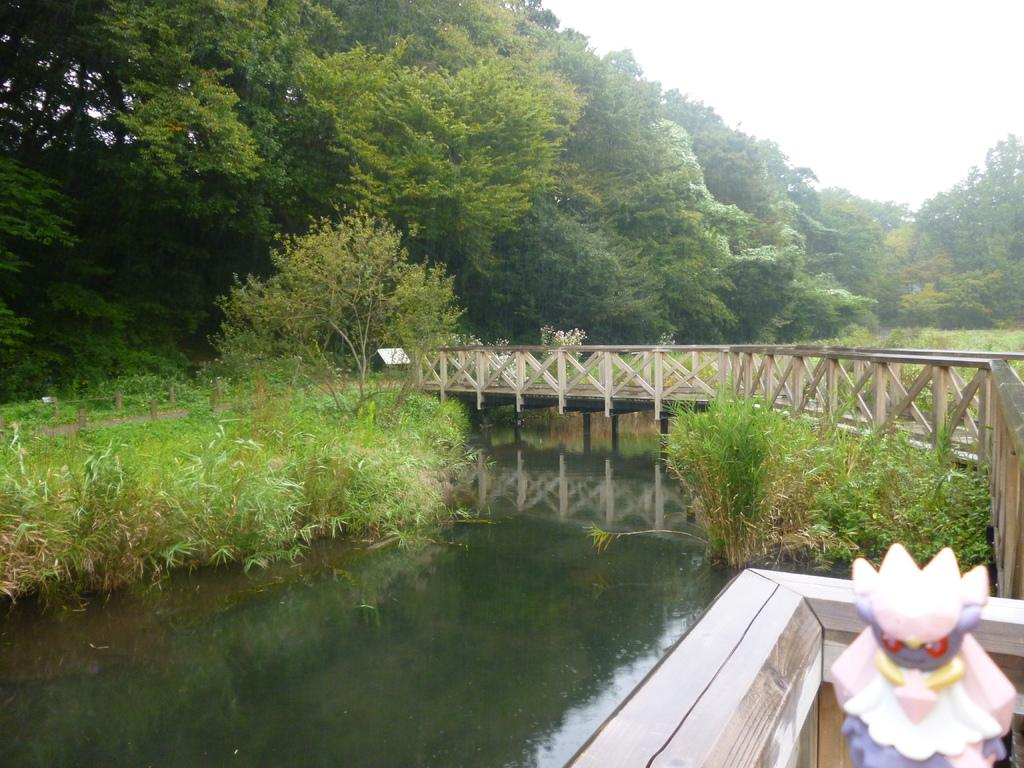What is the main element in the image? There is water in the image. What structure can be seen in the image? There is a bridge in the image. What type of object is present in the image? There is a toy in the image. What type of vegetation is visible in the image? There are plants and trees in the image. What other objects can be seen in the image? There are some objects in the image. What is visible in the background of the image? The sky is visible in the background of the image. How does the water breathe in the image? Water does not breathe; it is a liquid and cannot perform respiratory functions like living organisms. 